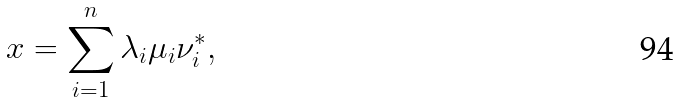Convert formula to latex. <formula><loc_0><loc_0><loc_500><loc_500>x = \sum _ { i = 1 } ^ { n } \lambda _ { i } \mu _ { i } \nu _ { i } ^ { * } ,</formula> 